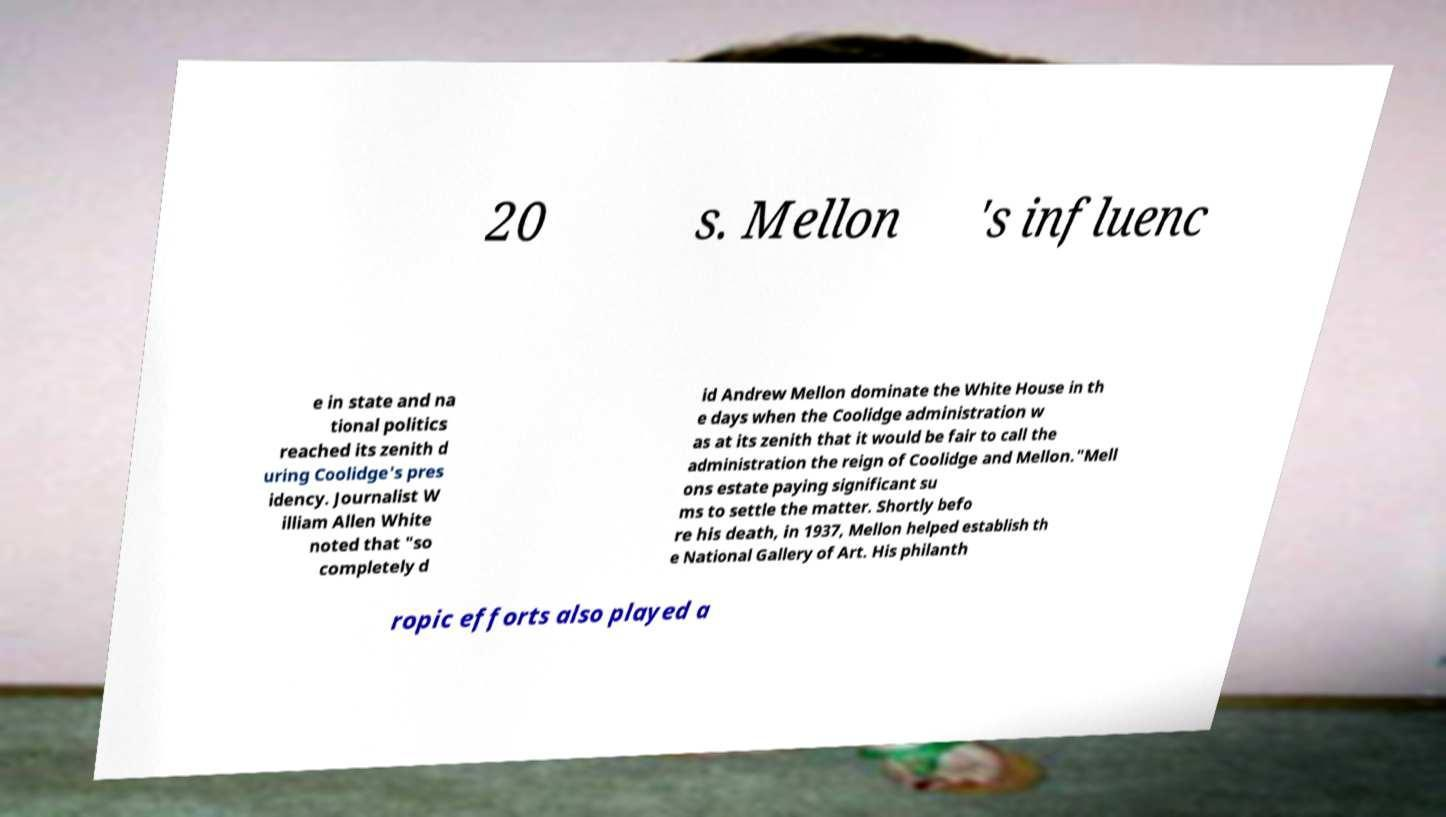I need the written content from this picture converted into text. Can you do that? 20 s. Mellon 's influenc e in state and na tional politics reached its zenith d uring Coolidge's pres idency. Journalist W illiam Allen White noted that "so completely d id Andrew Mellon dominate the White House in th e days when the Coolidge administration w as at its zenith that it would be fair to call the administration the reign of Coolidge and Mellon."Mell ons estate paying significant su ms to settle the matter. Shortly befo re his death, in 1937, Mellon helped establish th e National Gallery of Art. His philanth ropic efforts also played a 